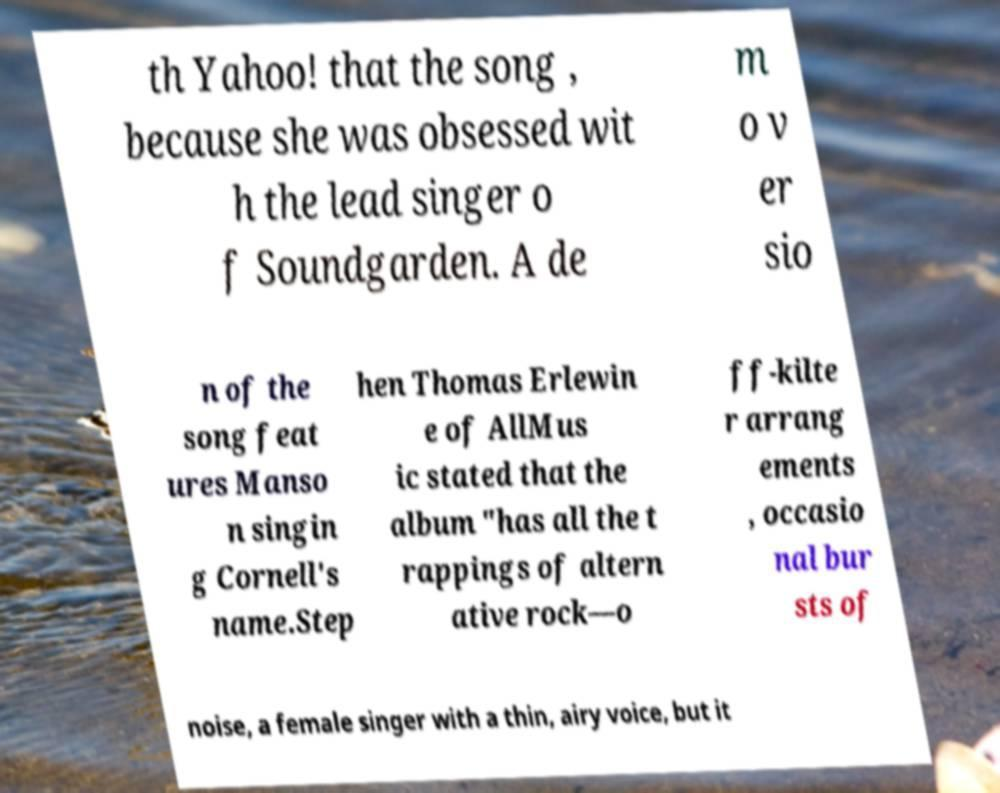What messages or text are displayed in this image? I need them in a readable, typed format. th Yahoo! that the song , because she was obsessed wit h the lead singer o f Soundgarden. A de m o v er sio n of the song feat ures Manso n singin g Cornell's name.Step hen Thomas Erlewin e of AllMus ic stated that the album "has all the t rappings of altern ative rock—o ff-kilte r arrang ements , occasio nal bur sts of noise, a female singer with a thin, airy voice, but it 